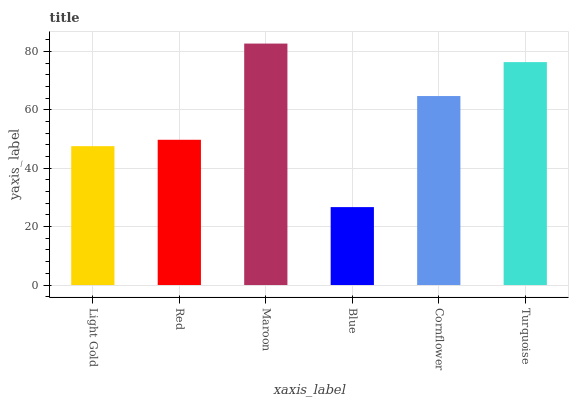Is Blue the minimum?
Answer yes or no. Yes. Is Maroon the maximum?
Answer yes or no. Yes. Is Red the minimum?
Answer yes or no. No. Is Red the maximum?
Answer yes or no. No. Is Red greater than Light Gold?
Answer yes or no. Yes. Is Light Gold less than Red?
Answer yes or no. Yes. Is Light Gold greater than Red?
Answer yes or no. No. Is Red less than Light Gold?
Answer yes or no. No. Is Cornflower the high median?
Answer yes or no. Yes. Is Red the low median?
Answer yes or no. Yes. Is Blue the high median?
Answer yes or no. No. Is Blue the low median?
Answer yes or no. No. 